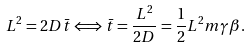<formula> <loc_0><loc_0><loc_500><loc_500>L ^ { 2 } = 2 D \bar { t } \Longleftrightarrow \bar { t } = \frac { L ^ { 2 } } { 2 D } = \frac { 1 } { 2 } L ^ { 2 } m \gamma \beta .</formula> 